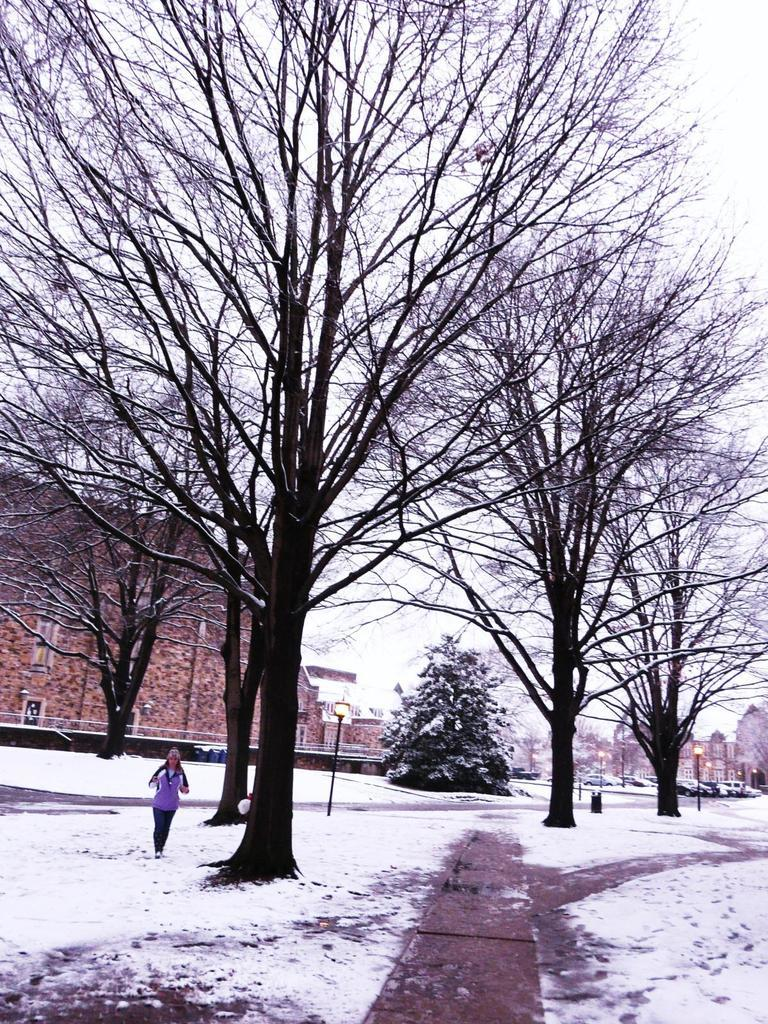What type of natural elements can be seen in the image? There are trees in the image. What type of man-made structures are present in the image? There are houses in the image. What type of lighting is present in the image? There are poles with lights in the image. What type of transportation is visible in the image? There are vehicles in the image. What is the person in the image doing? A person is standing on the snow. What is visible in the background of the image? The sky is visible in the background of the image. Can you tell me how many ghosts are present in the image? There are no ghosts present in the image; it features trees, houses, poles with lights, vehicles, a person standing on the snow, and a visible sky in the background. 